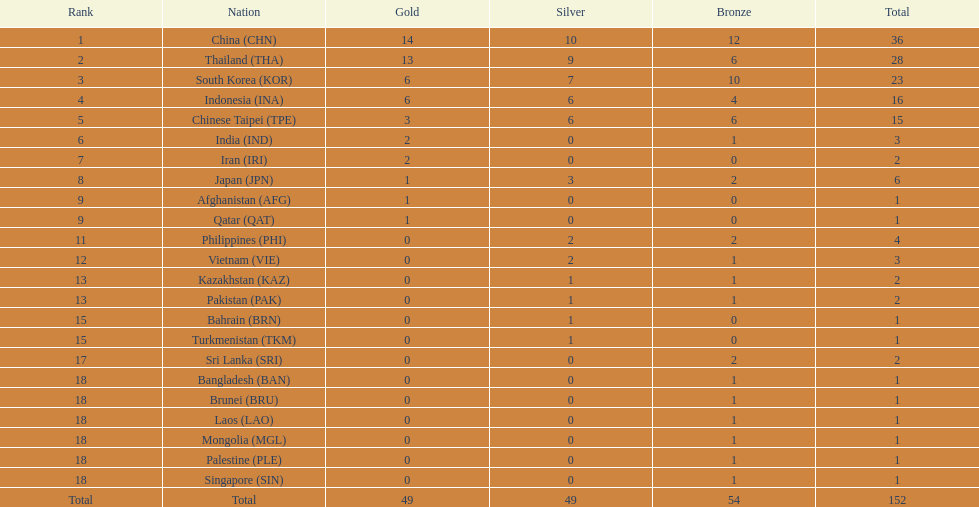Which nation ranked first for the total number of medals won? China (CHN). 